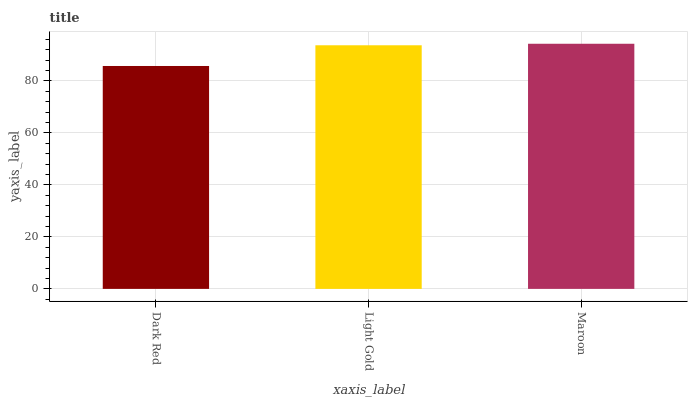Is Light Gold the minimum?
Answer yes or no. No. Is Light Gold the maximum?
Answer yes or no. No. Is Light Gold greater than Dark Red?
Answer yes or no. Yes. Is Dark Red less than Light Gold?
Answer yes or no. Yes. Is Dark Red greater than Light Gold?
Answer yes or no. No. Is Light Gold less than Dark Red?
Answer yes or no. No. Is Light Gold the high median?
Answer yes or no. Yes. Is Light Gold the low median?
Answer yes or no. Yes. Is Dark Red the high median?
Answer yes or no. No. Is Dark Red the low median?
Answer yes or no. No. 